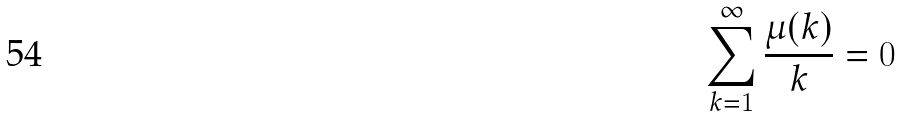Convert formula to latex. <formula><loc_0><loc_0><loc_500><loc_500>\sum _ { k = 1 } ^ { \infty } \frac { \mu ( k ) } { k } = 0</formula> 